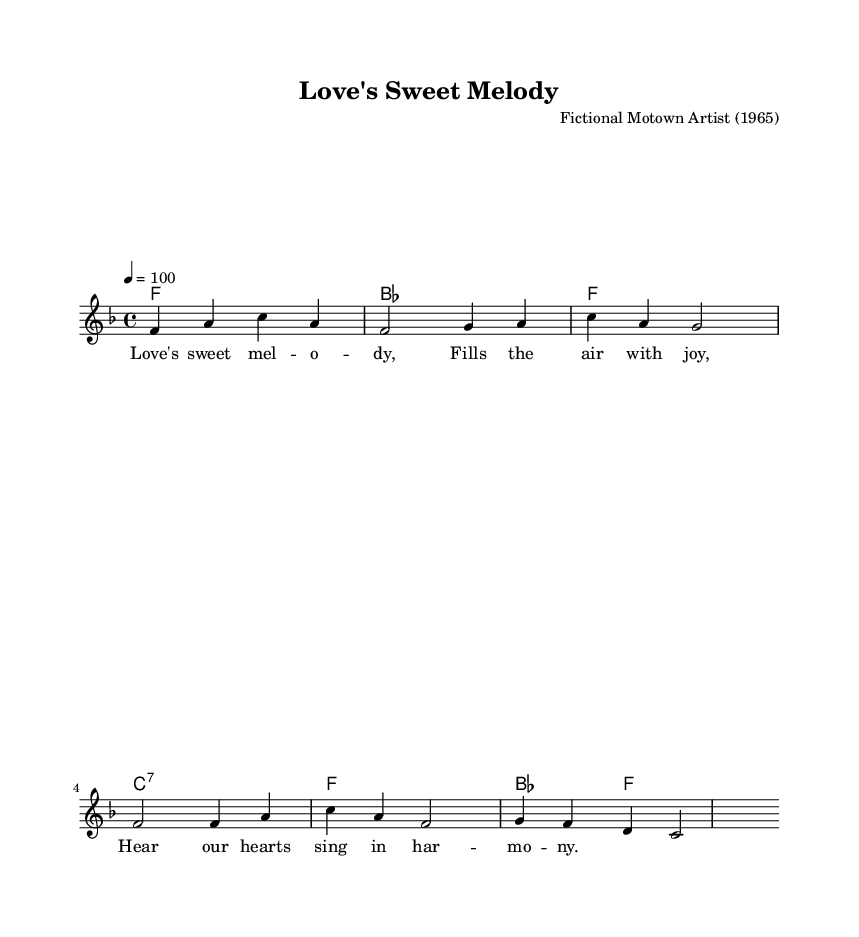What is the key signature of this music? The key signature is indicated at the beginning of the score with the \key command. In this case, it shows 'f' which indicates that the music is in F major, containing one flat.
Answer: F major What is the time signature of this music? The time signature is shown at the beginning of the score with the \time command. Here, it indicates 4/4, meaning there are four beats per measure, and the quarter note gets one beat.
Answer: 4/4 What is the tempo marking of the piece? The tempo is provided through the \tempo command, indicating 4 beats per minute. This shows how fast the music should be played, which in this piece is set to 100.
Answer: 100 How many measures are in the melody? By counting each measure within the melody section of the score, it is observed that there are six measures in total.
Answer: 6 What is the first chord in the harmony? The first chord is identified in the harmonies section with the first entry, which shows 'f1'. This means the chord is F major played as a whole note.
Answer: F What distinct characteristic does the melody of this soul piece have compared to typical pop melodies? Soul music often incorporates more emotional phrasing and a call-and-response structure, but here, the melody presents a smooth lyrical line typical in soulful expressions, reflecting deep emotion through its simple, yet heartfelt progression.
Answer: Smooth lyrical line What is the primary emotion conveyed through the lyrics of this piece? Analyzing the lyrics of this piece, sentiments of love and joy are prominent; terms like "Love's sweet melody" signify affection and happiness, common themes in soul music.
Answer: Joy 